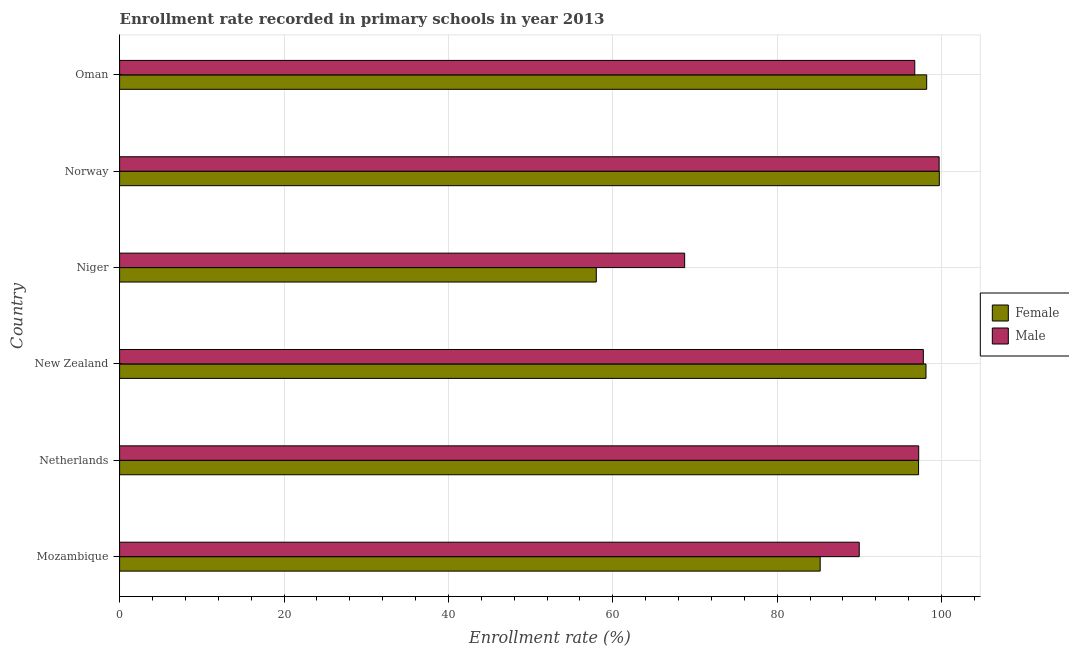How many different coloured bars are there?
Provide a short and direct response. 2. How many bars are there on the 6th tick from the top?
Your answer should be compact. 2. What is the label of the 2nd group of bars from the top?
Provide a succinct answer. Norway. In how many cases, is the number of bars for a given country not equal to the number of legend labels?
Offer a terse response. 0. What is the enrollment rate of female students in Oman?
Keep it short and to the point. 98.19. Across all countries, what is the maximum enrollment rate of female students?
Your response must be concise. 99.72. Across all countries, what is the minimum enrollment rate of female students?
Offer a terse response. 57.99. In which country was the enrollment rate of male students maximum?
Keep it short and to the point. Norway. In which country was the enrollment rate of female students minimum?
Give a very brief answer. Niger. What is the total enrollment rate of male students in the graph?
Keep it short and to the point. 550.15. What is the difference between the enrollment rate of male students in New Zealand and that in Norway?
Provide a short and direct response. -1.92. What is the difference between the enrollment rate of female students in Mozambique and the enrollment rate of male students in Niger?
Your response must be concise. 16.49. What is the average enrollment rate of male students per country?
Give a very brief answer. 91.69. What is the difference between the enrollment rate of male students and enrollment rate of female students in Norway?
Provide a succinct answer. -0.02. In how many countries, is the enrollment rate of male students greater than 12 %?
Your answer should be compact. 6. What is the ratio of the enrollment rate of male students in Mozambique to that in Oman?
Ensure brevity in your answer.  0.93. Is the enrollment rate of male students in Netherlands less than that in Norway?
Offer a terse response. Yes. What is the difference between the highest and the second highest enrollment rate of female students?
Your answer should be very brief. 1.54. What is the difference between the highest and the lowest enrollment rate of male students?
Offer a very short reply. 30.96. In how many countries, is the enrollment rate of male students greater than the average enrollment rate of male students taken over all countries?
Provide a short and direct response. 4. What does the 1st bar from the bottom in Oman represents?
Keep it short and to the point. Female. How many bars are there?
Ensure brevity in your answer.  12. Are all the bars in the graph horizontal?
Provide a succinct answer. Yes. How many countries are there in the graph?
Ensure brevity in your answer.  6. What is the difference between two consecutive major ticks on the X-axis?
Give a very brief answer. 20. Does the graph contain any zero values?
Provide a short and direct response. No. Where does the legend appear in the graph?
Ensure brevity in your answer.  Center right. What is the title of the graph?
Offer a terse response. Enrollment rate recorded in primary schools in year 2013. Does "Travel Items" appear as one of the legend labels in the graph?
Keep it short and to the point. No. What is the label or title of the X-axis?
Ensure brevity in your answer.  Enrollment rate (%). What is the label or title of the Y-axis?
Keep it short and to the point. Country. What is the Enrollment rate (%) of Female in Mozambique?
Your response must be concise. 85.23. What is the Enrollment rate (%) in Male in Mozambique?
Provide a short and direct response. 89.98. What is the Enrollment rate (%) in Female in Netherlands?
Provide a short and direct response. 97.2. What is the Enrollment rate (%) in Male in Netherlands?
Your response must be concise. 97.21. What is the Enrollment rate (%) of Female in New Zealand?
Give a very brief answer. 98.1. What is the Enrollment rate (%) of Male in New Zealand?
Your answer should be very brief. 97.78. What is the Enrollment rate (%) in Female in Niger?
Your answer should be very brief. 57.99. What is the Enrollment rate (%) in Male in Niger?
Provide a succinct answer. 68.74. What is the Enrollment rate (%) in Female in Norway?
Offer a very short reply. 99.72. What is the Enrollment rate (%) in Male in Norway?
Your answer should be compact. 99.7. What is the Enrollment rate (%) in Female in Oman?
Keep it short and to the point. 98.19. What is the Enrollment rate (%) of Male in Oman?
Provide a succinct answer. 96.73. Across all countries, what is the maximum Enrollment rate (%) of Female?
Ensure brevity in your answer.  99.72. Across all countries, what is the maximum Enrollment rate (%) in Male?
Keep it short and to the point. 99.7. Across all countries, what is the minimum Enrollment rate (%) in Female?
Your answer should be compact. 57.99. Across all countries, what is the minimum Enrollment rate (%) in Male?
Provide a succinct answer. 68.74. What is the total Enrollment rate (%) in Female in the graph?
Your response must be concise. 536.43. What is the total Enrollment rate (%) of Male in the graph?
Offer a very short reply. 550.15. What is the difference between the Enrollment rate (%) of Female in Mozambique and that in Netherlands?
Give a very brief answer. -11.97. What is the difference between the Enrollment rate (%) of Male in Mozambique and that in Netherlands?
Provide a short and direct response. -7.23. What is the difference between the Enrollment rate (%) of Female in Mozambique and that in New Zealand?
Offer a terse response. -12.87. What is the difference between the Enrollment rate (%) in Male in Mozambique and that in New Zealand?
Offer a very short reply. -7.8. What is the difference between the Enrollment rate (%) in Female in Mozambique and that in Niger?
Provide a short and direct response. 27.24. What is the difference between the Enrollment rate (%) in Male in Mozambique and that in Niger?
Make the answer very short. 21.24. What is the difference between the Enrollment rate (%) of Female in Mozambique and that in Norway?
Make the answer very short. -14.49. What is the difference between the Enrollment rate (%) in Male in Mozambique and that in Norway?
Your answer should be compact. -9.72. What is the difference between the Enrollment rate (%) in Female in Mozambique and that in Oman?
Keep it short and to the point. -12.96. What is the difference between the Enrollment rate (%) in Male in Mozambique and that in Oman?
Your response must be concise. -6.75. What is the difference between the Enrollment rate (%) in Female in Netherlands and that in New Zealand?
Keep it short and to the point. -0.9. What is the difference between the Enrollment rate (%) of Male in Netherlands and that in New Zealand?
Ensure brevity in your answer.  -0.56. What is the difference between the Enrollment rate (%) in Female in Netherlands and that in Niger?
Your answer should be compact. 39.2. What is the difference between the Enrollment rate (%) in Male in Netherlands and that in Niger?
Your response must be concise. 28.47. What is the difference between the Enrollment rate (%) of Female in Netherlands and that in Norway?
Your answer should be compact. -2.52. What is the difference between the Enrollment rate (%) of Male in Netherlands and that in Norway?
Make the answer very short. -2.49. What is the difference between the Enrollment rate (%) in Female in Netherlands and that in Oman?
Ensure brevity in your answer.  -0.99. What is the difference between the Enrollment rate (%) in Male in Netherlands and that in Oman?
Your answer should be compact. 0.48. What is the difference between the Enrollment rate (%) in Female in New Zealand and that in Niger?
Offer a terse response. 40.11. What is the difference between the Enrollment rate (%) of Male in New Zealand and that in Niger?
Ensure brevity in your answer.  29.04. What is the difference between the Enrollment rate (%) in Female in New Zealand and that in Norway?
Ensure brevity in your answer.  -1.62. What is the difference between the Enrollment rate (%) in Male in New Zealand and that in Norway?
Ensure brevity in your answer.  -1.92. What is the difference between the Enrollment rate (%) in Female in New Zealand and that in Oman?
Make the answer very short. -0.08. What is the difference between the Enrollment rate (%) in Male in New Zealand and that in Oman?
Offer a very short reply. 1.04. What is the difference between the Enrollment rate (%) of Female in Niger and that in Norway?
Make the answer very short. -41.73. What is the difference between the Enrollment rate (%) of Male in Niger and that in Norway?
Offer a terse response. -30.96. What is the difference between the Enrollment rate (%) in Female in Niger and that in Oman?
Offer a very short reply. -40.19. What is the difference between the Enrollment rate (%) of Male in Niger and that in Oman?
Your answer should be very brief. -27.99. What is the difference between the Enrollment rate (%) in Female in Norway and that in Oman?
Offer a very short reply. 1.54. What is the difference between the Enrollment rate (%) in Male in Norway and that in Oman?
Ensure brevity in your answer.  2.97. What is the difference between the Enrollment rate (%) of Female in Mozambique and the Enrollment rate (%) of Male in Netherlands?
Give a very brief answer. -11.98. What is the difference between the Enrollment rate (%) in Female in Mozambique and the Enrollment rate (%) in Male in New Zealand?
Ensure brevity in your answer.  -12.55. What is the difference between the Enrollment rate (%) in Female in Mozambique and the Enrollment rate (%) in Male in Niger?
Your answer should be compact. 16.49. What is the difference between the Enrollment rate (%) of Female in Mozambique and the Enrollment rate (%) of Male in Norway?
Ensure brevity in your answer.  -14.47. What is the difference between the Enrollment rate (%) in Female in Mozambique and the Enrollment rate (%) in Male in Oman?
Keep it short and to the point. -11.5. What is the difference between the Enrollment rate (%) of Female in Netherlands and the Enrollment rate (%) of Male in New Zealand?
Ensure brevity in your answer.  -0.58. What is the difference between the Enrollment rate (%) in Female in Netherlands and the Enrollment rate (%) in Male in Niger?
Your response must be concise. 28.46. What is the difference between the Enrollment rate (%) in Female in Netherlands and the Enrollment rate (%) in Male in Norway?
Offer a terse response. -2.5. What is the difference between the Enrollment rate (%) of Female in Netherlands and the Enrollment rate (%) of Male in Oman?
Offer a terse response. 0.46. What is the difference between the Enrollment rate (%) in Female in New Zealand and the Enrollment rate (%) in Male in Niger?
Give a very brief answer. 29.36. What is the difference between the Enrollment rate (%) in Female in New Zealand and the Enrollment rate (%) in Male in Norway?
Provide a succinct answer. -1.6. What is the difference between the Enrollment rate (%) in Female in New Zealand and the Enrollment rate (%) in Male in Oman?
Your response must be concise. 1.37. What is the difference between the Enrollment rate (%) of Female in Niger and the Enrollment rate (%) of Male in Norway?
Your answer should be compact. -41.71. What is the difference between the Enrollment rate (%) of Female in Niger and the Enrollment rate (%) of Male in Oman?
Your answer should be compact. -38.74. What is the difference between the Enrollment rate (%) in Female in Norway and the Enrollment rate (%) in Male in Oman?
Keep it short and to the point. 2.99. What is the average Enrollment rate (%) in Female per country?
Your answer should be compact. 89.41. What is the average Enrollment rate (%) of Male per country?
Offer a very short reply. 91.69. What is the difference between the Enrollment rate (%) of Female and Enrollment rate (%) of Male in Mozambique?
Offer a terse response. -4.75. What is the difference between the Enrollment rate (%) of Female and Enrollment rate (%) of Male in Netherlands?
Give a very brief answer. -0.02. What is the difference between the Enrollment rate (%) of Female and Enrollment rate (%) of Male in New Zealand?
Give a very brief answer. 0.32. What is the difference between the Enrollment rate (%) in Female and Enrollment rate (%) in Male in Niger?
Offer a very short reply. -10.75. What is the difference between the Enrollment rate (%) of Female and Enrollment rate (%) of Male in Norway?
Provide a short and direct response. 0.02. What is the difference between the Enrollment rate (%) in Female and Enrollment rate (%) in Male in Oman?
Ensure brevity in your answer.  1.45. What is the ratio of the Enrollment rate (%) in Female in Mozambique to that in Netherlands?
Your answer should be very brief. 0.88. What is the ratio of the Enrollment rate (%) in Male in Mozambique to that in Netherlands?
Keep it short and to the point. 0.93. What is the ratio of the Enrollment rate (%) in Female in Mozambique to that in New Zealand?
Offer a terse response. 0.87. What is the ratio of the Enrollment rate (%) in Male in Mozambique to that in New Zealand?
Your answer should be compact. 0.92. What is the ratio of the Enrollment rate (%) in Female in Mozambique to that in Niger?
Provide a short and direct response. 1.47. What is the ratio of the Enrollment rate (%) of Male in Mozambique to that in Niger?
Your response must be concise. 1.31. What is the ratio of the Enrollment rate (%) in Female in Mozambique to that in Norway?
Make the answer very short. 0.85. What is the ratio of the Enrollment rate (%) in Male in Mozambique to that in Norway?
Offer a very short reply. 0.9. What is the ratio of the Enrollment rate (%) of Female in Mozambique to that in Oman?
Provide a succinct answer. 0.87. What is the ratio of the Enrollment rate (%) in Male in Mozambique to that in Oman?
Provide a short and direct response. 0.93. What is the ratio of the Enrollment rate (%) in Male in Netherlands to that in New Zealand?
Provide a short and direct response. 0.99. What is the ratio of the Enrollment rate (%) in Female in Netherlands to that in Niger?
Provide a short and direct response. 1.68. What is the ratio of the Enrollment rate (%) in Male in Netherlands to that in Niger?
Provide a succinct answer. 1.41. What is the ratio of the Enrollment rate (%) of Female in Netherlands to that in Norway?
Keep it short and to the point. 0.97. What is the ratio of the Enrollment rate (%) of Male in Netherlands to that in Norway?
Your response must be concise. 0.98. What is the ratio of the Enrollment rate (%) in Female in New Zealand to that in Niger?
Provide a succinct answer. 1.69. What is the ratio of the Enrollment rate (%) in Male in New Zealand to that in Niger?
Offer a very short reply. 1.42. What is the ratio of the Enrollment rate (%) of Female in New Zealand to that in Norway?
Your response must be concise. 0.98. What is the ratio of the Enrollment rate (%) of Male in New Zealand to that in Norway?
Your answer should be very brief. 0.98. What is the ratio of the Enrollment rate (%) of Female in New Zealand to that in Oman?
Give a very brief answer. 1. What is the ratio of the Enrollment rate (%) of Male in New Zealand to that in Oman?
Keep it short and to the point. 1.01. What is the ratio of the Enrollment rate (%) in Female in Niger to that in Norway?
Your response must be concise. 0.58. What is the ratio of the Enrollment rate (%) of Male in Niger to that in Norway?
Ensure brevity in your answer.  0.69. What is the ratio of the Enrollment rate (%) of Female in Niger to that in Oman?
Your response must be concise. 0.59. What is the ratio of the Enrollment rate (%) of Male in Niger to that in Oman?
Offer a very short reply. 0.71. What is the ratio of the Enrollment rate (%) in Female in Norway to that in Oman?
Provide a succinct answer. 1.02. What is the ratio of the Enrollment rate (%) in Male in Norway to that in Oman?
Your answer should be very brief. 1.03. What is the difference between the highest and the second highest Enrollment rate (%) of Female?
Make the answer very short. 1.54. What is the difference between the highest and the second highest Enrollment rate (%) of Male?
Make the answer very short. 1.92. What is the difference between the highest and the lowest Enrollment rate (%) of Female?
Provide a succinct answer. 41.73. What is the difference between the highest and the lowest Enrollment rate (%) in Male?
Ensure brevity in your answer.  30.96. 